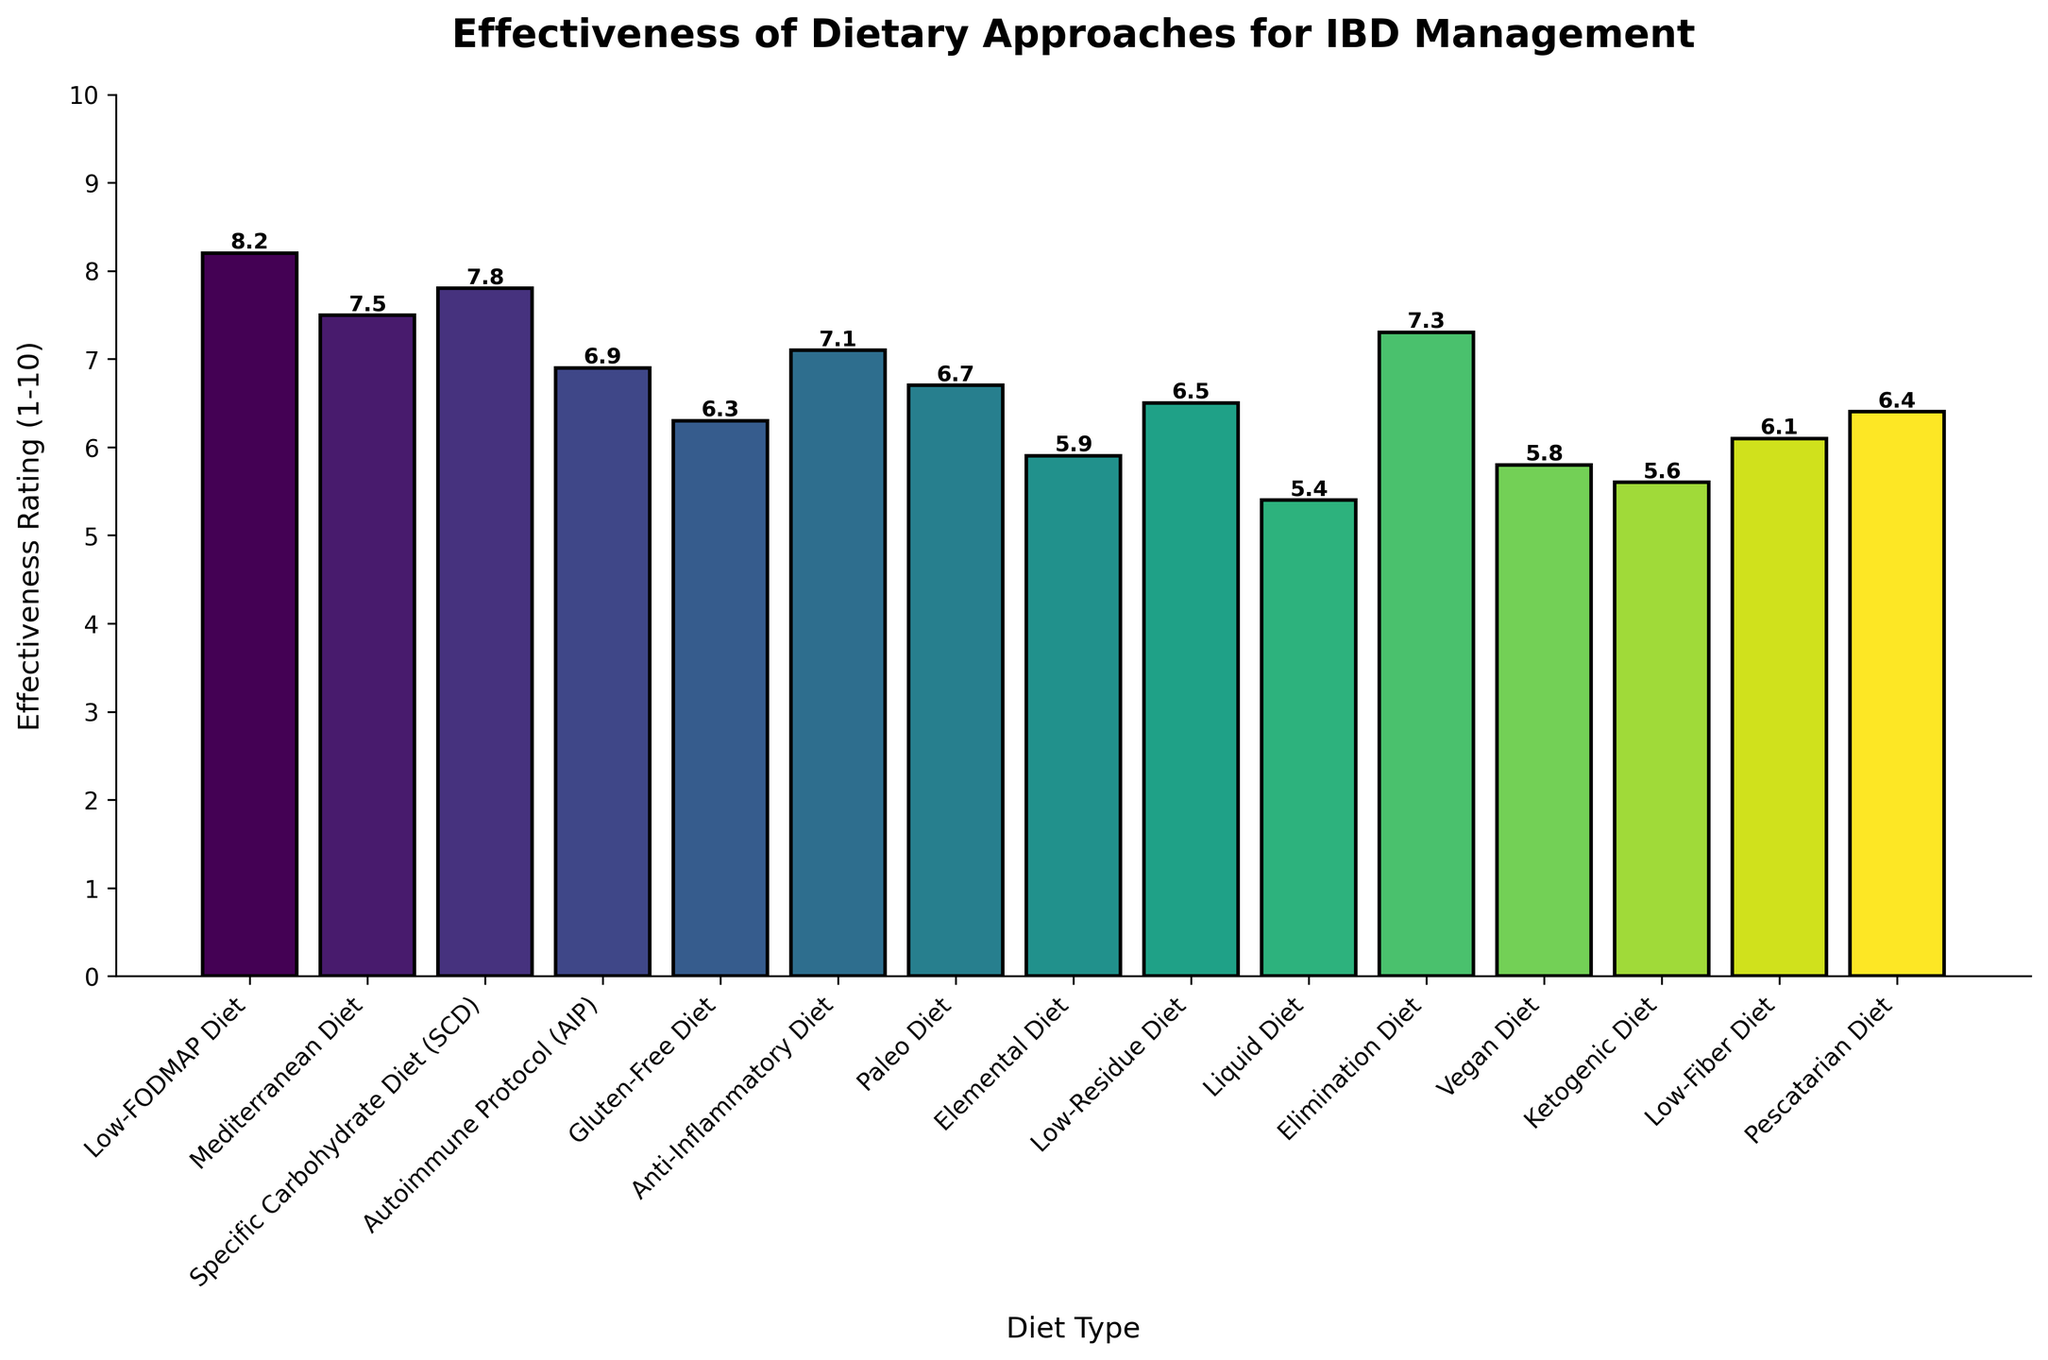What is the average effectiveness rating of the top three diets? The top three diets by effectiveness rating are the Low-FODMAP Diet (8.2), Specific Carbohydrate Diet (7.8), and Mediterranean Diet (7.5). Their average rating is calculated as follows: (8.2 + 7.8 + 7.5) / 3 = 7.83.
Answer: 7.83 Which diet has the highest effectiveness rating, and what is the rating? By examining the heights of the bars, the Low-FODMAP Diet has the highest effectiveness rating, which is 8.2.
Answer: Low-FODMAP Diet, 8.2 How many diets have an effectiveness rating higher than 7? To find this, identify the bars with heights above 7. These include: Low-FODMAP Diet (8.2), Specific Carbohydrate Diet (7.8), Mediterranean Diet (7.5), and Elimination Diet (7.3). There are 4 diets in total.
Answer: 4 What's the effectiveness rating difference between the diet with the highest rating and the diet with the lowest rating? The highest-rated diet is the Low-FODMAP Diet with a rating of 8.2, and the lowest-rated diet is the Liquid Diet with a rating of 5.4. The difference is calculated as 8.2 - 5.4 = 2.8.
Answer: 2.8 Which diet has the lowest effectiveness rating, and what is the rating? By examining the heights of the bars, the Liquid Diet has the lowest effectiveness rating, which is 5.4.
Answer: Liquid Diet, 5.4 What is the combined effectiveness rating of the Anti-Inflammatory Diet and Paleo Diet? The effectiveness rating for the Anti-Inflammatory Diet is 7.1, and for the Paleo Diet, it is 6.7. Adding these gives 7.1 + 6.7 = 13.8.
Answer: 13.8 Which diet has an effectiveness rating closest to 6.5? To find this, look for the bar whose height is closest to 6.5. The Low-Residue Diet has an exact rating of 6.5.
Answer: Low-Residue Diet What is the effectiveness rating range among all the diets? The range is calculated by subtracting the lowest rating (Liquid Diet, 5.4) from the highest rating (Low-FODMAP Diet, 8.2). The range is 8.2 - 5.4 = 2.8.
Answer: 2.8 How many diets have an effectiveness rating below 6? Identify the bars with heights below 6, which include Elemental Diet (5.9), Liquid Diet (5.4), Vegan Diet (5.8), and Ketogenic Diet (5.6). There are 4 diets in total.
Answer: 4 Is the effectiveness rating of the Gluten-Free Diet higher or lower than the average rating of all diets? The average rating for all diets is calculated first: sum of all ratings (8.2 + 7.5 + 7.8 + 6.9 + 6.3 + 7.1 + 6.7 + 5.9 + 6.5 + 5.4 + 7.3 + 5.8 + 5.6 + 6.1 + 6.4) / 15 = 6.6. The effectiveness rating of the Gluten-Free Diet is 6.3, which is lower than the average rating of 6.6.
Answer: Lower 